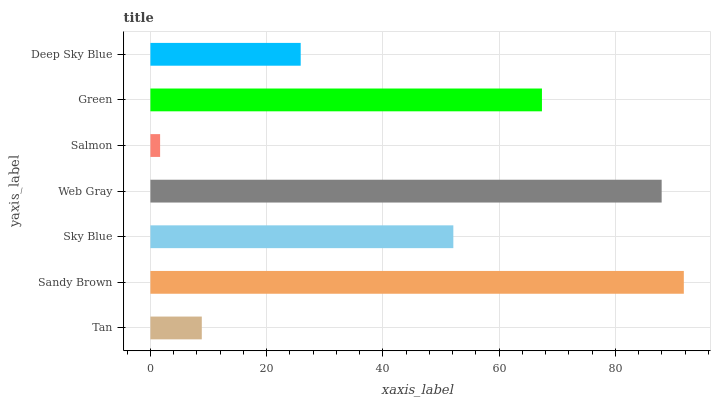Is Salmon the minimum?
Answer yes or no. Yes. Is Sandy Brown the maximum?
Answer yes or no. Yes. Is Sky Blue the minimum?
Answer yes or no. No. Is Sky Blue the maximum?
Answer yes or no. No. Is Sandy Brown greater than Sky Blue?
Answer yes or no. Yes. Is Sky Blue less than Sandy Brown?
Answer yes or no. Yes. Is Sky Blue greater than Sandy Brown?
Answer yes or no. No. Is Sandy Brown less than Sky Blue?
Answer yes or no. No. Is Sky Blue the high median?
Answer yes or no. Yes. Is Sky Blue the low median?
Answer yes or no. Yes. Is Salmon the high median?
Answer yes or no. No. Is Green the low median?
Answer yes or no. No. 